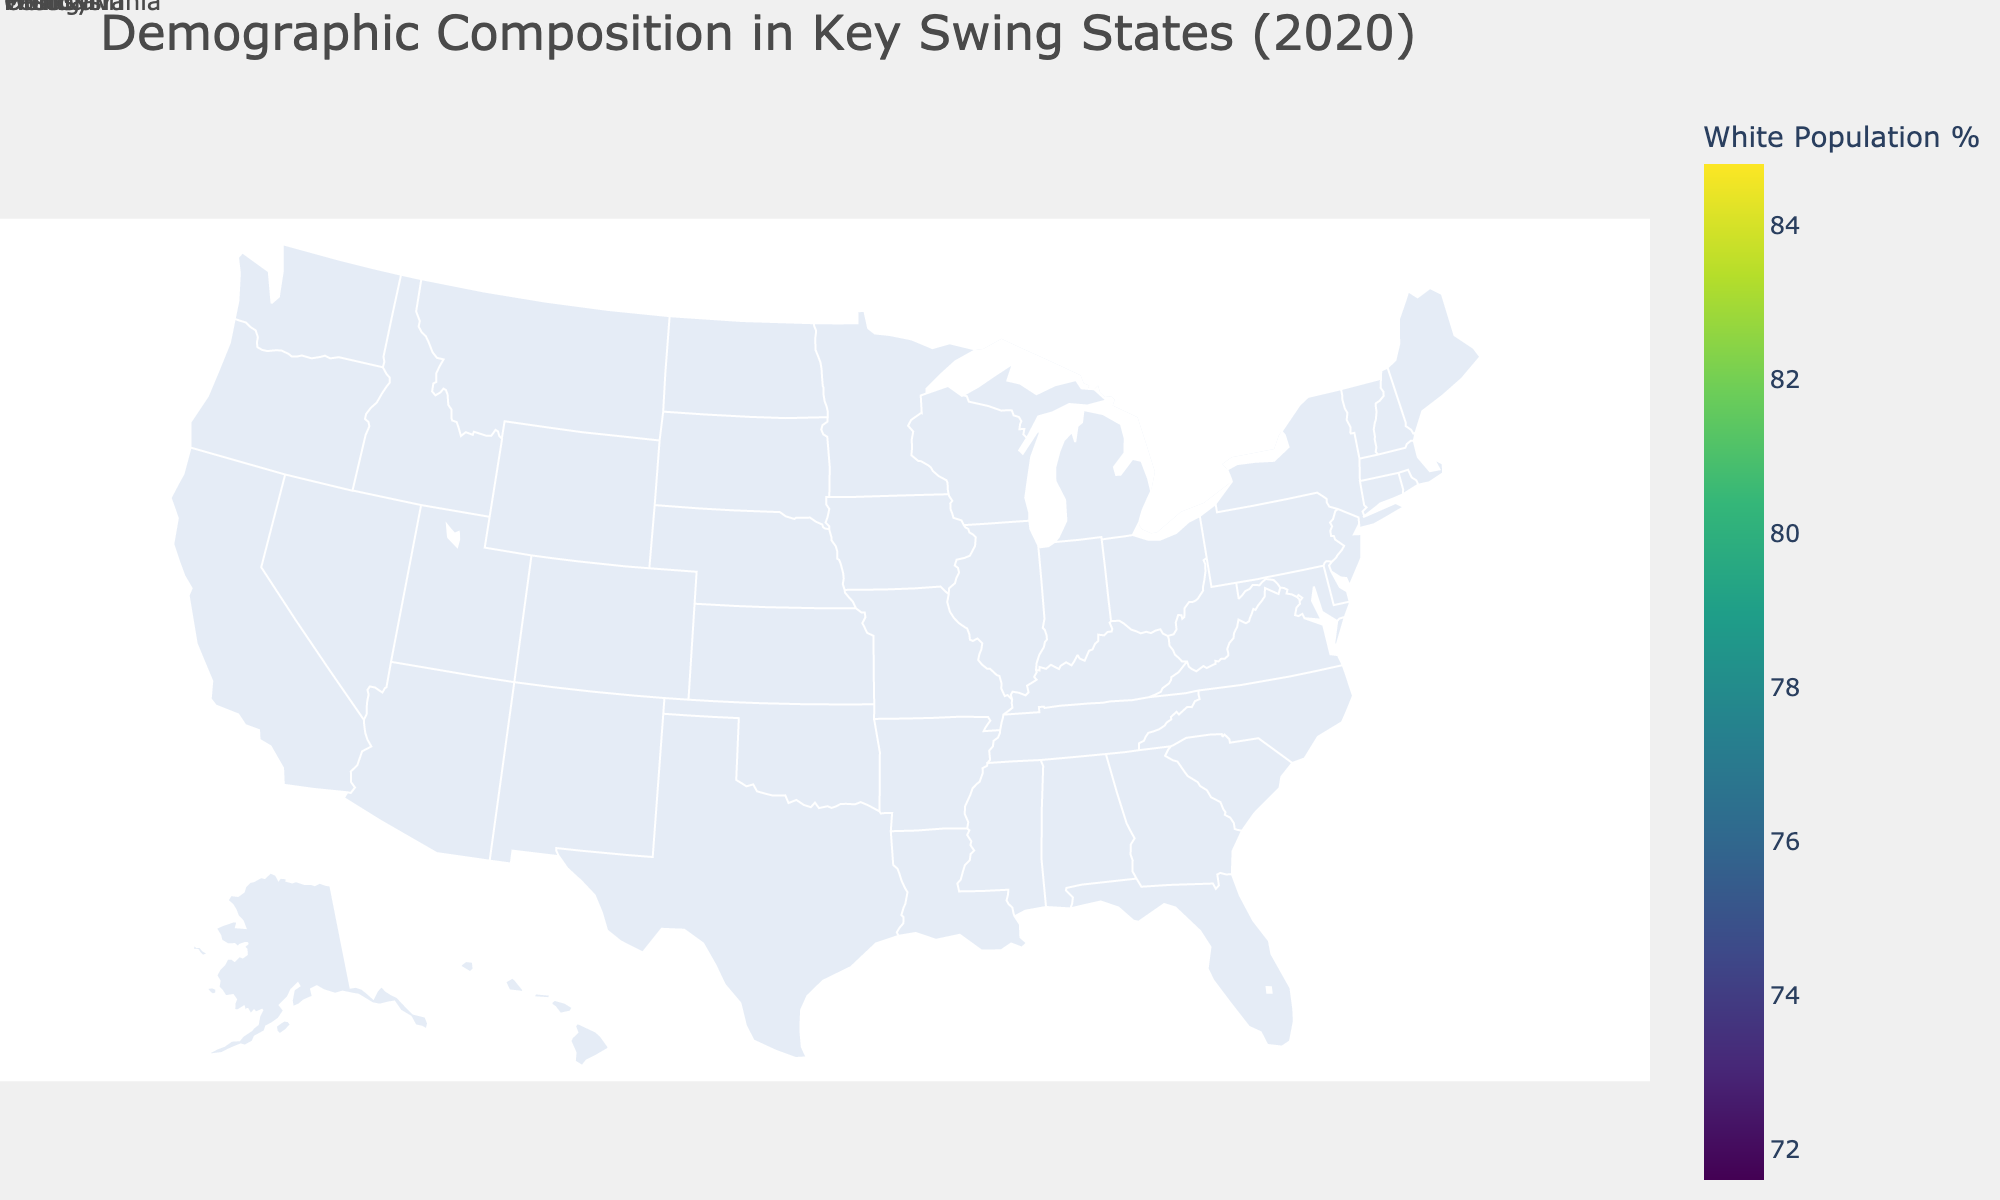How many key swing states are shown in the figure? There are five states in the data (Florida, Pennsylvania, Ohio, Michigan, and Wisconsin). Each state is included in the figure.
Answer: 5 Which state has the highest percentage of White population in 2020? Examine all the states' White population percentages provided in the figure and identify the highest one. The data indicates that Wisconsin has the highest percentage at 84.8%.
Answer: Wisconsin What is the percentage change in Hispanic population in Pennsylvania from 2000 to 2020? Subtract the Hispanic population percentage in 2000 from that in 2020: 7.8% - 3.2% = 4.6%.
Answer: 4.6% Compare the percentage of Black population in Ohio and Michigan in 2020. Which state has a higher percentage? Look at the percentages of Black population in Ohio (12.4%) and Michigan (13.7%) in 2020. Michigan has a higher percentage.
Answer: Michigan Which state shows the largest increase in the Asian population percentage from 2000 to 2020? Calculate the change in Asian population percentage for each state between 2000 and 2020. Florida shows the largest increase from 1.7% to 3.0%, a change of 1.3%.
Answer: Florida How does the percentage of the population aged 65+ in Florida in 2000 compare to 2020? Compare the aged 65+ percentages in Florida for 2000 (17.2%) and 2020 (21.3%). The percentage increased by 4.1%.
Answer: Increased by 4.1% Which state had the smallest change in the White population percentage from 2000 to 2020? Compare the changes in the White population percentage for each state. Michigan’s percentage decreased by 1.8% from 80.2% to 78.4%, the smallest change among the states.
Answer: Michigan What is the combined percentage of the Hispanic and Black populations in Florida in 2020? Add the Hispanic percentage (26.5%) to the Black percentage (15.1%) in Florida for 2020. The combined percentage is 41.6%.
Answer: 41.6% Which state had the largest increase in the percentage of populations aged 65+ from 2000 to 2020? Calculate the change in the percentage of populations aged 65+ for each state. Florida had the largest increase, from 17.2% to 21.3%, an increase of 4.1%.
Answer: Florida Which state had the smallest Hispanic population percentage in 2020? Identify the state with the lowest Hispanic population percentage in 2020 from the data. Ohio has the smallest at 4.0%.
Answer: Ohio 